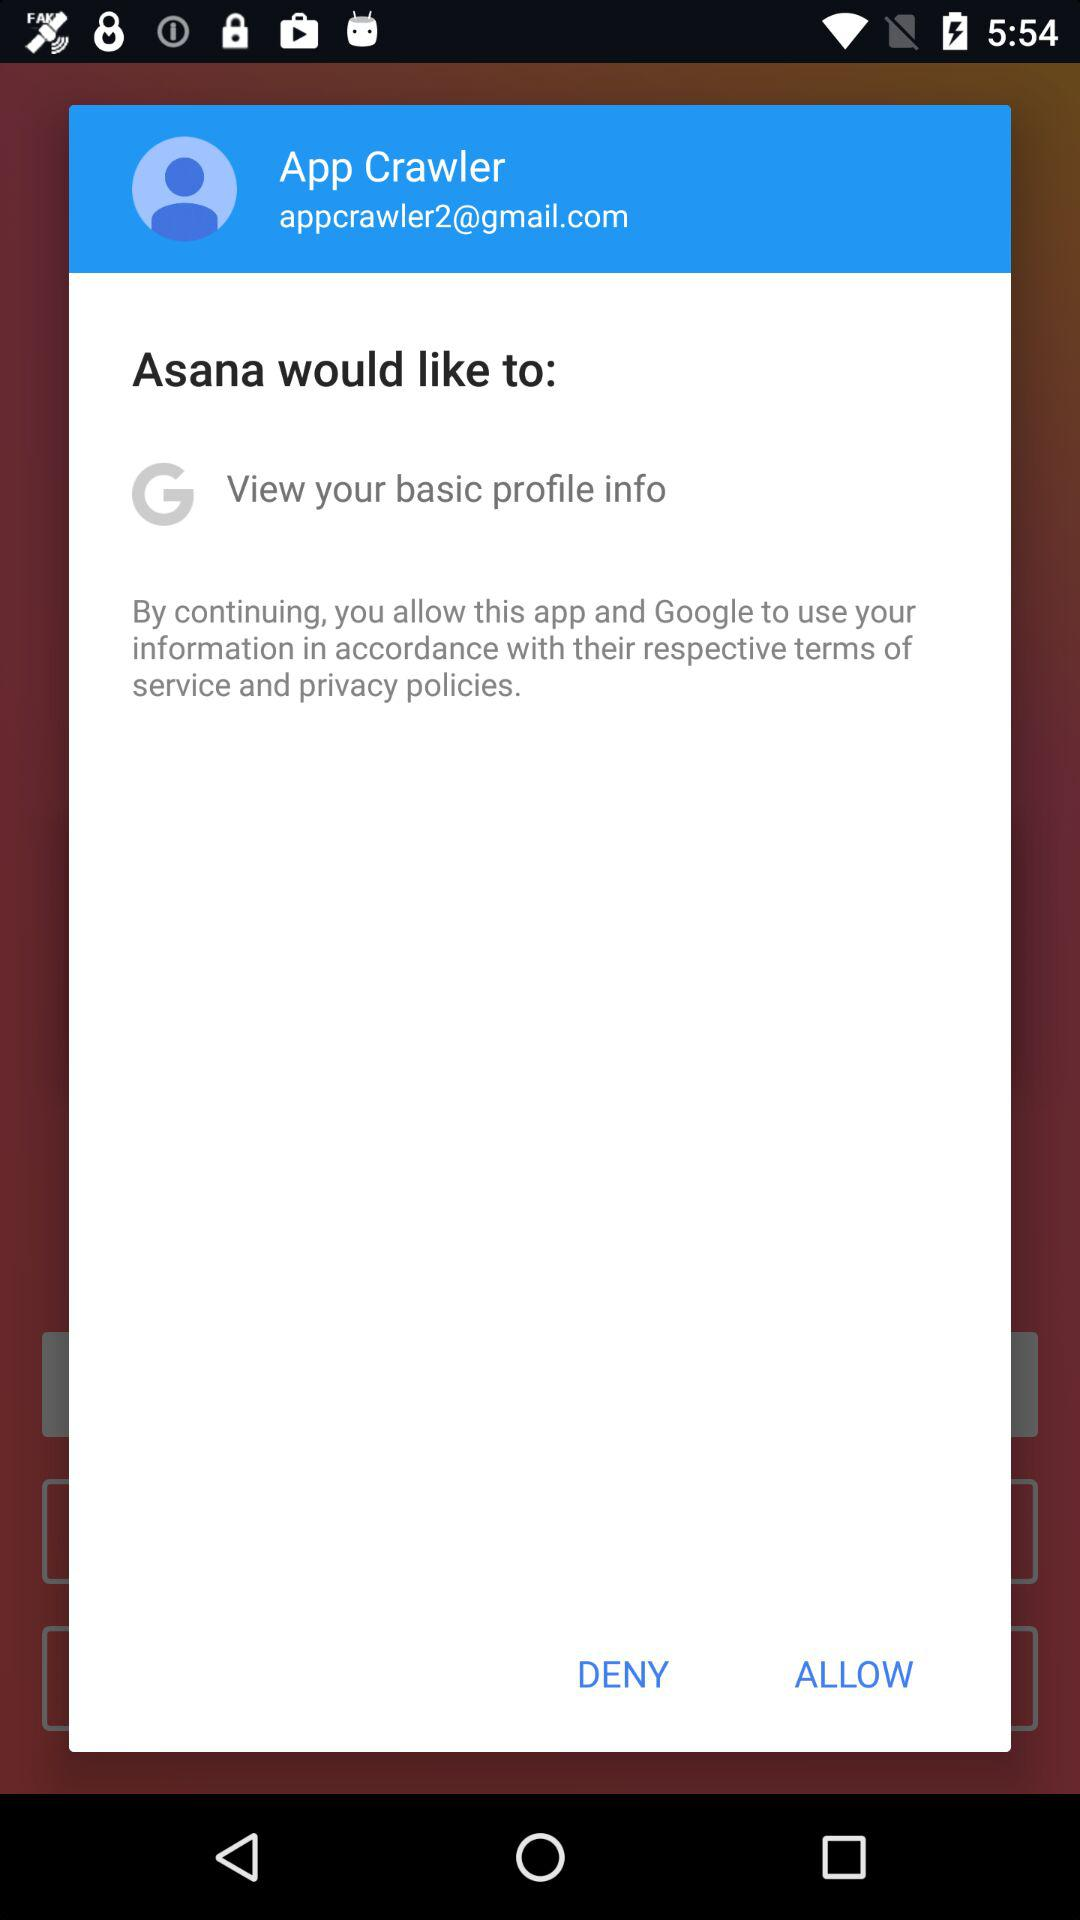Who would like to view basic profile information? The basic profile information would be liked by Asana. 